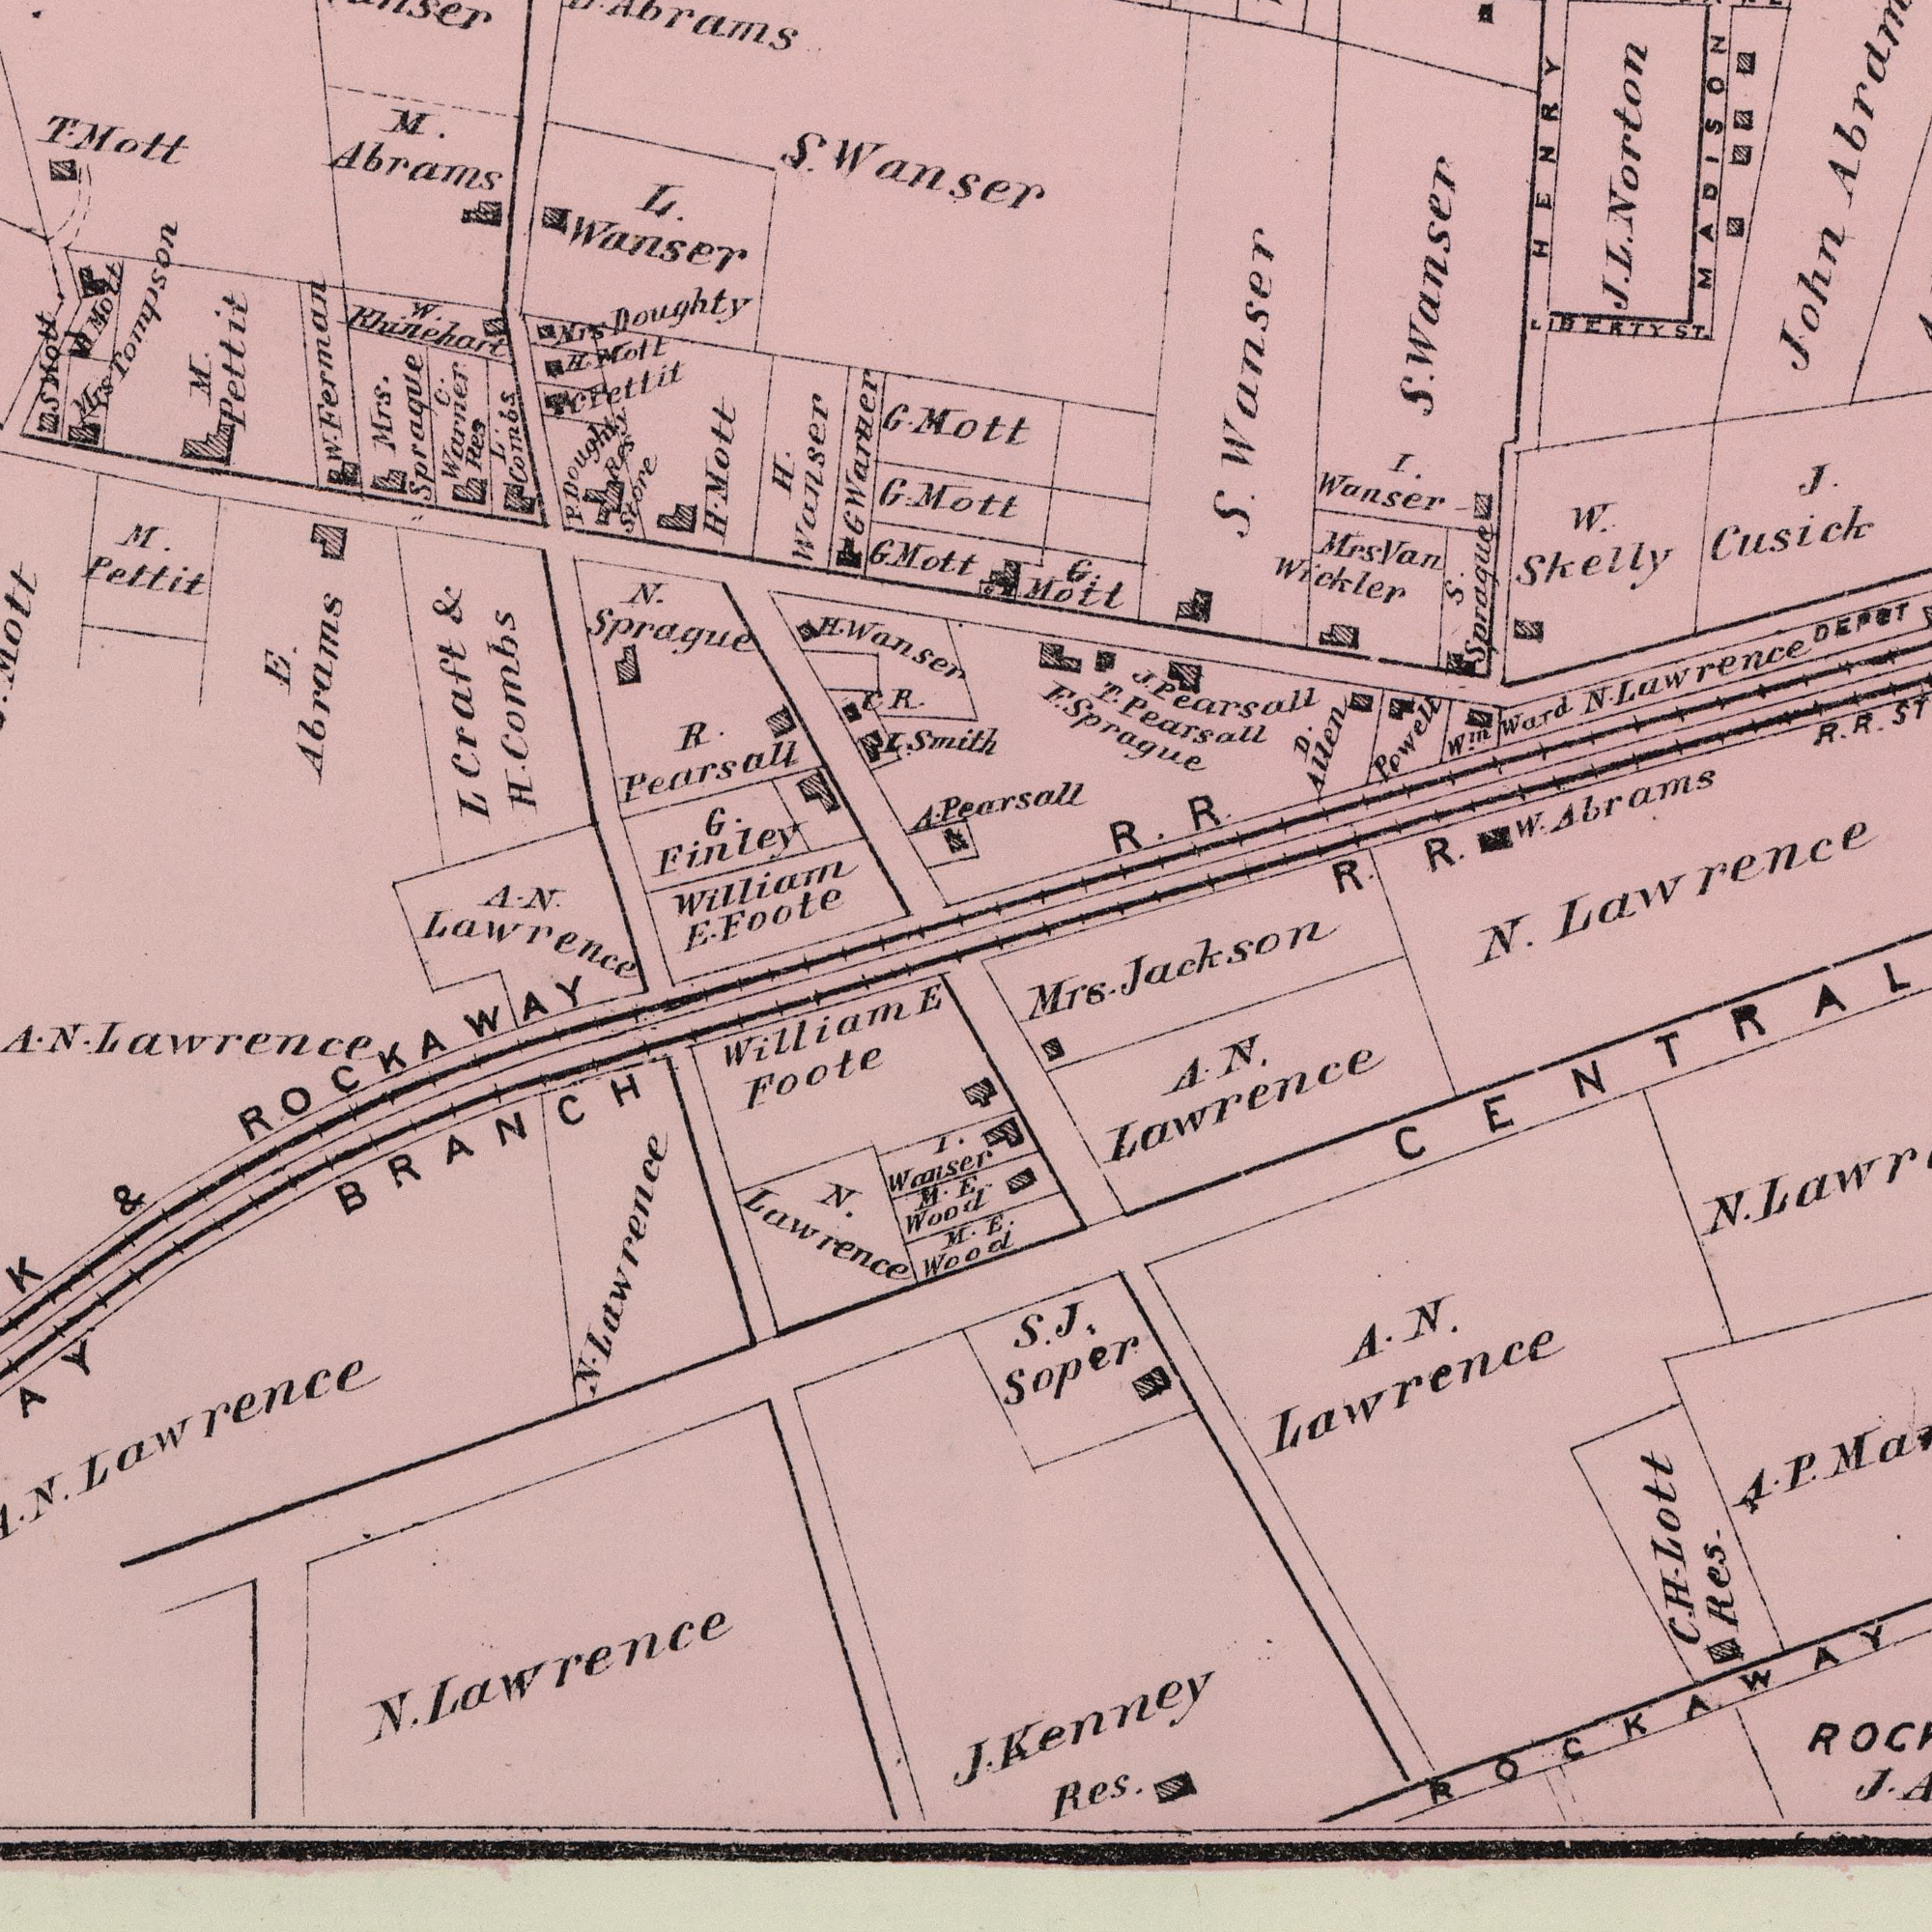What text can you see in the top-left section? N. Sprague T. Mott M. Abrams Mrs Tompson H. Mott A. N. Mrs. Spraque W. Khinehart M. Pettit W. Ferman L. Wanser H. Wanser L Craft & G. Finley William Mrs Doughty Foote G. Abrams H. Wansen S Mott H. Combs E. Abrams C. Warner Res Res Store G Warner R. Pearsall L. Combs C. Fetttit M. Pettit C. R. G. Mott G. A. P. Doughty H. Mott S. Wanser L. Smith G. Mott H Molt What text can you see in the bottom-right section? N. Mrs. Jackson E. Wood E. S. J. Soper C. H. Lott Res. A. N. Lawrence A. N. Lawrence J. N. J. Kenney Res. A. P. ROCKAWAY CENTRAL What text appears in the bottom-left area of the image? Lawrence E. William E Foote BRANCH M. N. Lawrence I. Wanser M. Wood N. Lawrence N. Lawrence A. N. Lawrence & ROCKAWAY A. N. Lawrence What text is visible in the upper-right corner? Mott Mott Pearsall Lawrence I. Wanser John HENRY S. Sprague R. Mrs Van Wickler N. Laawrence J. Cusick T. Pearsall Win Ward S. Swanser R. R. DEPOT G. Mott W. Skelly Powell S. Wanser MADISON D. Allen R. J. L. Norton F. Sprague J. Pearsall R. R. LIBERTY ST. W. Abrams 